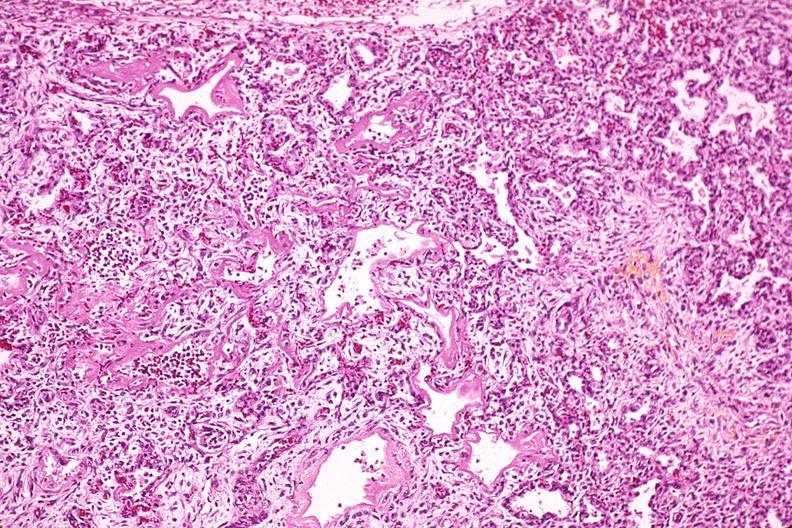s respiratory present?
Answer the question using a single word or phrase. Yes 